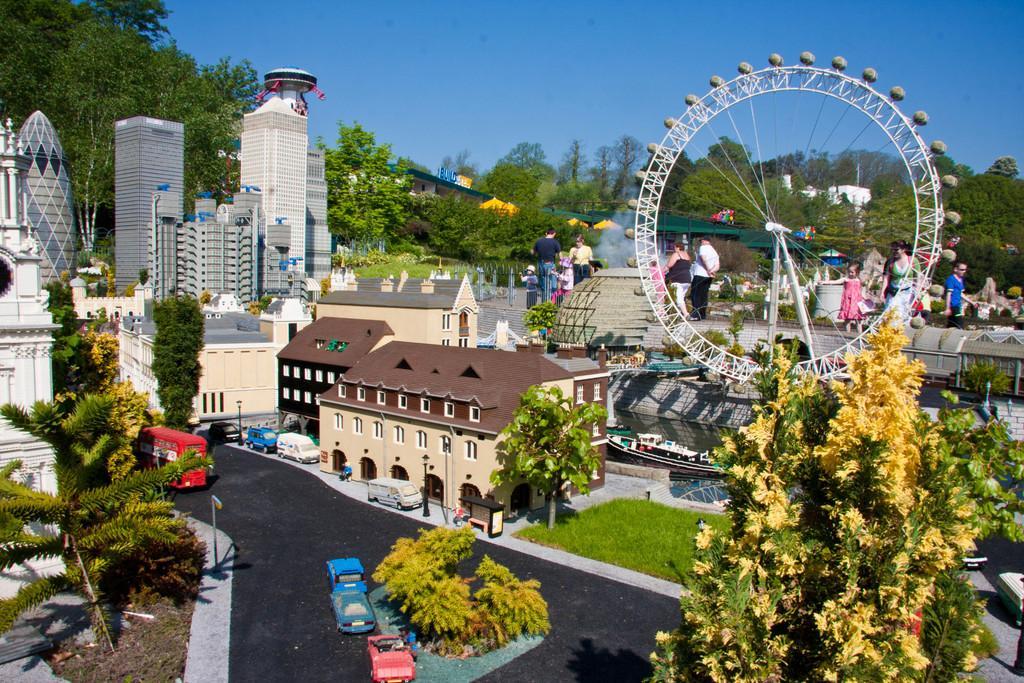Please provide a concise description of this image. In this image it looks like a miniature in the foreground, There is a road, there are vehicles, buildings, trees. There are people, trees, buildings and there is a metal object on the right corner. There are trees in the background. And there is sky at the top. 